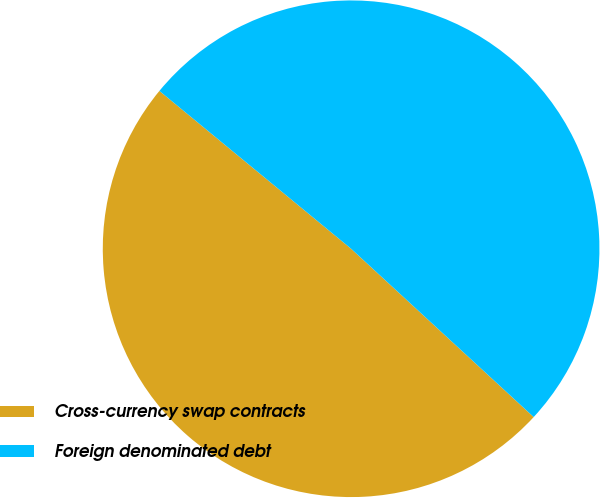Convert chart. <chart><loc_0><loc_0><loc_500><loc_500><pie_chart><fcel>Cross-currency swap contracts<fcel>Foreign denominated debt<nl><fcel>49.11%<fcel>50.89%<nl></chart> 